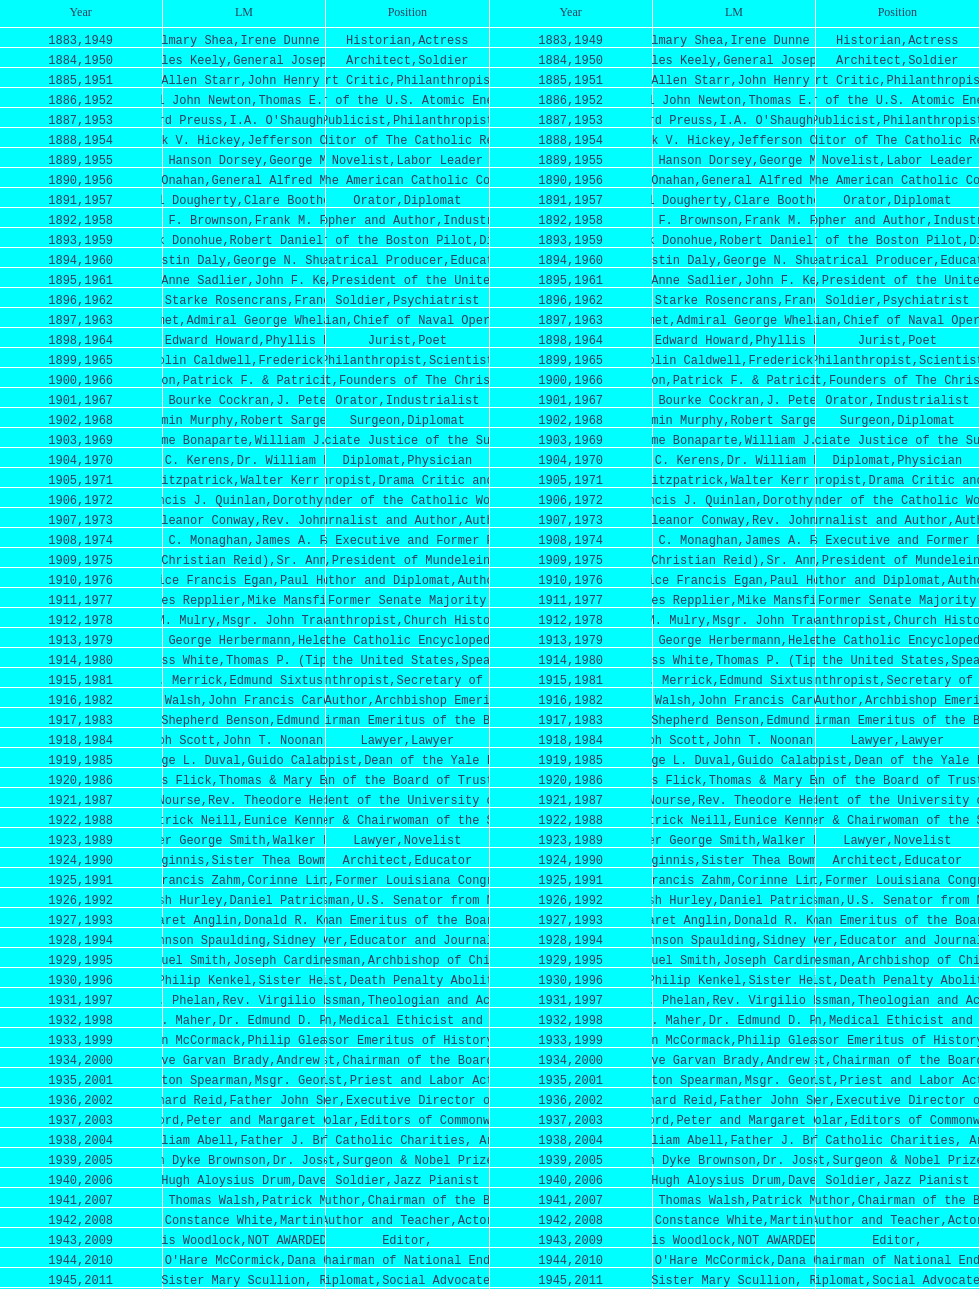How many are or were journalists? 5. 